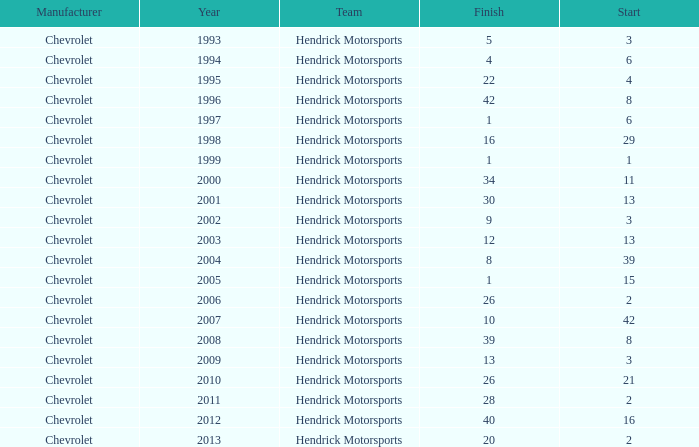Which team had a start of 8 in years under 2008? Hendrick Motorsports. 